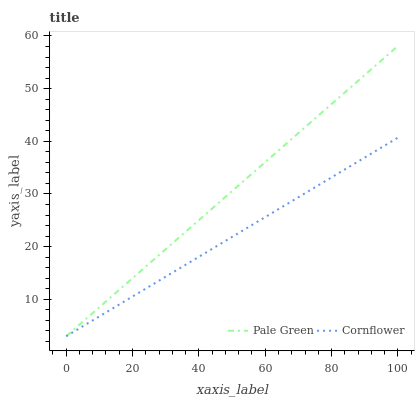Does Cornflower have the minimum area under the curve?
Answer yes or no. Yes. Does Pale Green have the maximum area under the curve?
Answer yes or no. Yes. Does Pale Green have the minimum area under the curve?
Answer yes or no. No. Is Cornflower the smoothest?
Answer yes or no. Yes. Is Pale Green the roughest?
Answer yes or no. Yes. Is Pale Green the smoothest?
Answer yes or no. No. Does Cornflower have the lowest value?
Answer yes or no. Yes. Does Pale Green have the highest value?
Answer yes or no. Yes. Does Pale Green intersect Cornflower?
Answer yes or no. Yes. Is Pale Green less than Cornflower?
Answer yes or no. No. Is Pale Green greater than Cornflower?
Answer yes or no. No. 